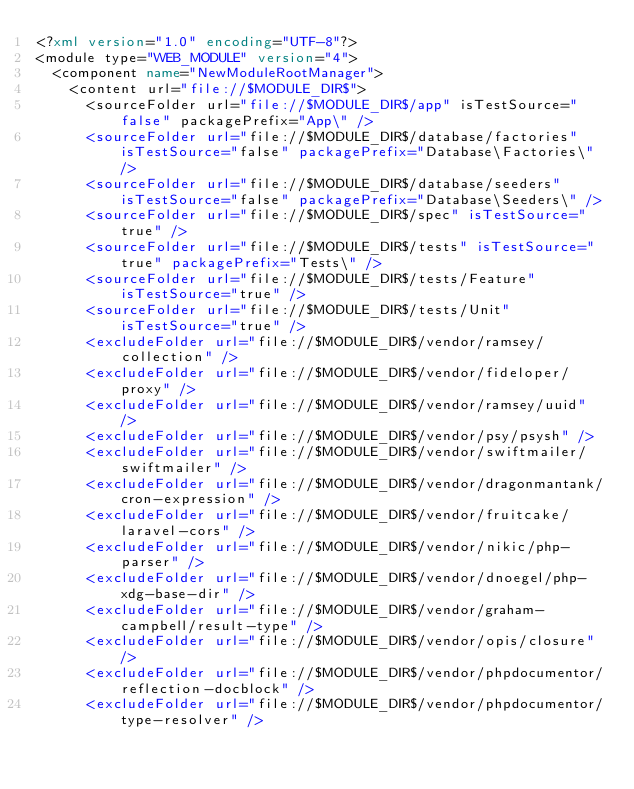Convert code to text. <code><loc_0><loc_0><loc_500><loc_500><_XML_><?xml version="1.0" encoding="UTF-8"?>
<module type="WEB_MODULE" version="4">
  <component name="NewModuleRootManager">
    <content url="file://$MODULE_DIR$">
      <sourceFolder url="file://$MODULE_DIR$/app" isTestSource="false" packagePrefix="App\" />
      <sourceFolder url="file://$MODULE_DIR$/database/factories" isTestSource="false" packagePrefix="Database\Factories\" />
      <sourceFolder url="file://$MODULE_DIR$/database/seeders" isTestSource="false" packagePrefix="Database\Seeders\" />
      <sourceFolder url="file://$MODULE_DIR$/spec" isTestSource="true" />
      <sourceFolder url="file://$MODULE_DIR$/tests" isTestSource="true" packagePrefix="Tests\" />
      <sourceFolder url="file://$MODULE_DIR$/tests/Feature" isTestSource="true" />
      <sourceFolder url="file://$MODULE_DIR$/tests/Unit" isTestSource="true" />
      <excludeFolder url="file://$MODULE_DIR$/vendor/ramsey/collection" />
      <excludeFolder url="file://$MODULE_DIR$/vendor/fideloper/proxy" />
      <excludeFolder url="file://$MODULE_DIR$/vendor/ramsey/uuid" />
      <excludeFolder url="file://$MODULE_DIR$/vendor/psy/psysh" />
      <excludeFolder url="file://$MODULE_DIR$/vendor/swiftmailer/swiftmailer" />
      <excludeFolder url="file://$MODULE_DIR$/vendor/dragonmantank/cron-expression" />
      <excludeFolder url="file://$MODULE_DIR$/vendor/fruitcake/laravel-cors" />
      <excludeFolder url="file://$MODULE_DIR$/vendor/nikic/php-parser" />
      <excludeFolder url="file://$MODULE_DIR$/vendor/dnoegel/php-xdg-base-dir" />
      <excludeFolder url="file://$MODULE_DIR$/vendor/graham-campbell/result-type" />
      <excludeFolder url="file://$MODULE_DIR$/vendor/opis/closure" />
      <excludeFolder url="file://$MODULE_DIR$/vendor/phpdocumentor/reflection-docblock" />
      <excludeFolder url="file://$MODULE_DIR$/vendor/phpdocumentor/type-resolver" /></code> 